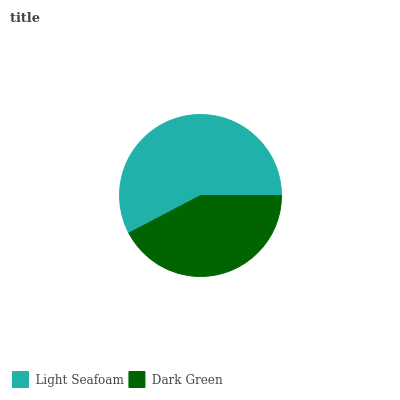Is Dark Green the minimum?
Answer yes or no. Yes. Is Light Seafoam the maximum?
Answer yes or no. Yes. Is Dark Green the maximum?
Answer yes or no. No. Is Light Seafoam greater than Dark Green?
Answer yes or no. Yes. Is Dark Green less than Light Seafoam?
Answer yes or no. Yes. Is Dark Green greater than Light Seafoam?
Answer yes or no. No. Is Light Seafoam less than Dark Green?
Answer yes or no. No. Is Light Seafoam the high median?
Answer yes or no. Yes. Is Dark Green the low median?
Answer yes or no. Yes. Is Dark Green the high median?
Answer yes or no. No. Is Light Seafoam the low median?
Answer yes or no. No. 